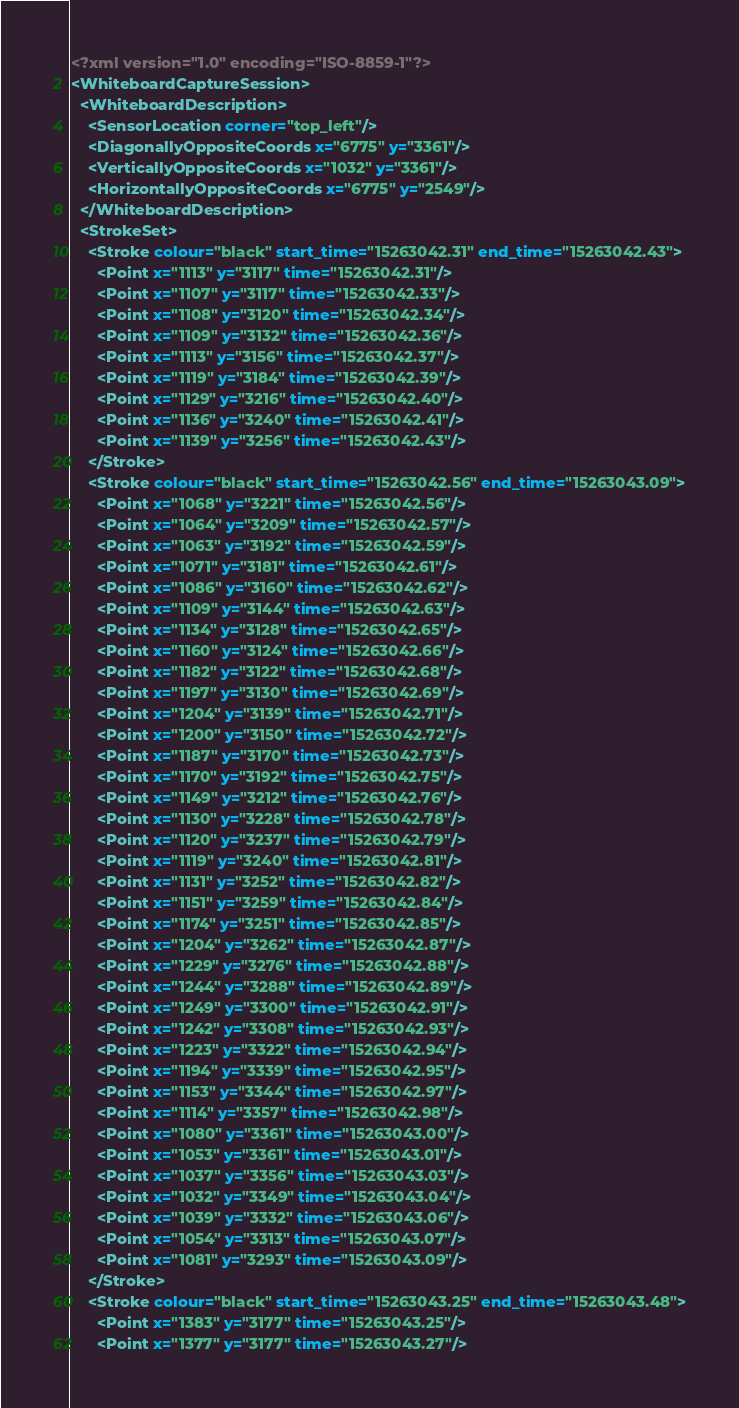Convert code to text. <code><loc_0><loc_0><loc_500><loc_500><_XML_><?xml version="1.0" encoding="ISO-8859-1"?>
<WhiteboardCaptureSession>
  <WhiteboardDescription>
    <SensorLocation corner="top_left"/>
    <DiagonallyOppositeCoords x="6775" y="3361"/>
    <VerticallyOppositeCoords x="1032" y="3361"/>
    <HorizontallyOppositeCoords x="6775" y="2549"/>
  </WhiteboardDescription>
  <StrokeSet>
    <Stroke colour="black" start_time="15263042.31" end_time="15263042.43">
      <Point x="1113" y="3117" time="15263042.31"/>
      <Point x="1107" y="3117" time="15263042.33"/>
      <Point x="1108" y="3120" time="15263042.34"/>
      <Point x="1109" y="3132" time="15263042.36"/>
      <Point x="1113" y="3156" time="15263042.37"/>
      <Point x="1119" y="3184" time="15263042.39"/>
      <Point x="1129" y="3216" time="15263042.40"/>
      <Point x="1136" y="3240" time="15263042.41"/>
      <Point x="1139" y="3256" time="15263042.43"/>
    </Stroke>
    <Stroke colour="black" start_time="15263042.56" end_time="15263043.09">
      <Point x="1068" y="3221" time="15263042.56"/>
      <Point x="1064" y="3209" time="15263042.57"/>
      <Point x="1063" y="3192" time="15263042.59"/>
      <Point x="1071" y="3181" time="15263042.61"/>
      <Point x="1086" y="3160" time="15263042.62"/>
      <Point x="1109" y="3144" time="15263042.63"/>
      <Point x="1134" y="3128" time="15263042.65"/>
      <Point x="1160" y="3124" time="15263042.66"/>
      <Point x="1182" y="3122" time="15263042.68"/>
      <Point x="1197" y="3130" time="15263042.69"/>
      <Point x="1204" y="3139" time="15263042.71"/>
      <Point x="1200" y="3150" time="15263042.72"/>
      <Point x="1187" y="3170" time="15263042.73"/>
      <Point x="1170" y="3192" time="15263042.75"/>
      <Point x="1149" y="3212" time="15263042.76"/>
      <Point x="1130" y="3228" time="15263042.78"/>
      <Point x="1120" y="3237" time="15263042.79"/>
      <Point x="1119" y="3240" time="15263042.81"/>
      <Point x="1131" y="3252" time="15263042.82"/>
      <Point x="1151" y="3259" time="15263042.84"/>
      <Point x="1174" y="3251" time="15263042.85"/>
      <Point x="1204" y="3262" time="15263042.87"/>
      <Point x="1229" y="3276" time="15263042.88"/>
      <Point x="1244" y="3288" time="15263042.89"/>
      <Point x="1249" y="3300" time="15263042.91"/>
      <Point x="1242" y="3308" time="15263042.93"/>
      <Point x="1223" y="3322" time="15263042.94"/>
      <Point x="1194" y="3339" time="15263042.95"/>
      <Point x="1153" y="3344" time="15263042.97"/>
      <Point x="1114" y="3357" time="15263042.98"/>
      <Point x="1080" y="3361" time="15263043.00"/>
      <Point x="1053" y="3361" time="15263043.01"/>
      <Point x="1037" y="3356" time="15263043.03"/>
      <Point x="1032" y="3349" time="15263043.04"/>
      <Point x="1039" y="3332" time="15263043.06"/>
      <Point x="1054" y="3313" time="15263043.07"/>
      <Point x="1081" y="3293" time="15263043.09"/>
    </Stroke>
    <Stroke colour="black" start_time="15263043.25" end_time="15263043.48">
      <Point x="1383" y="3177" time="15263043.25"/>
      <Point x="1377" y="3177" time="15263043.27"/></code> 